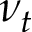<formula> <loc_0><loc_0><loc_500><loc_500>\nu _ { t }</formula> 